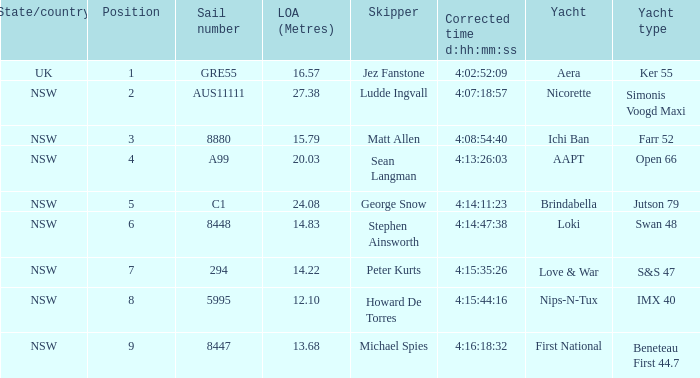What is the ranking for NSW open 66 racing boat.  4.0. 